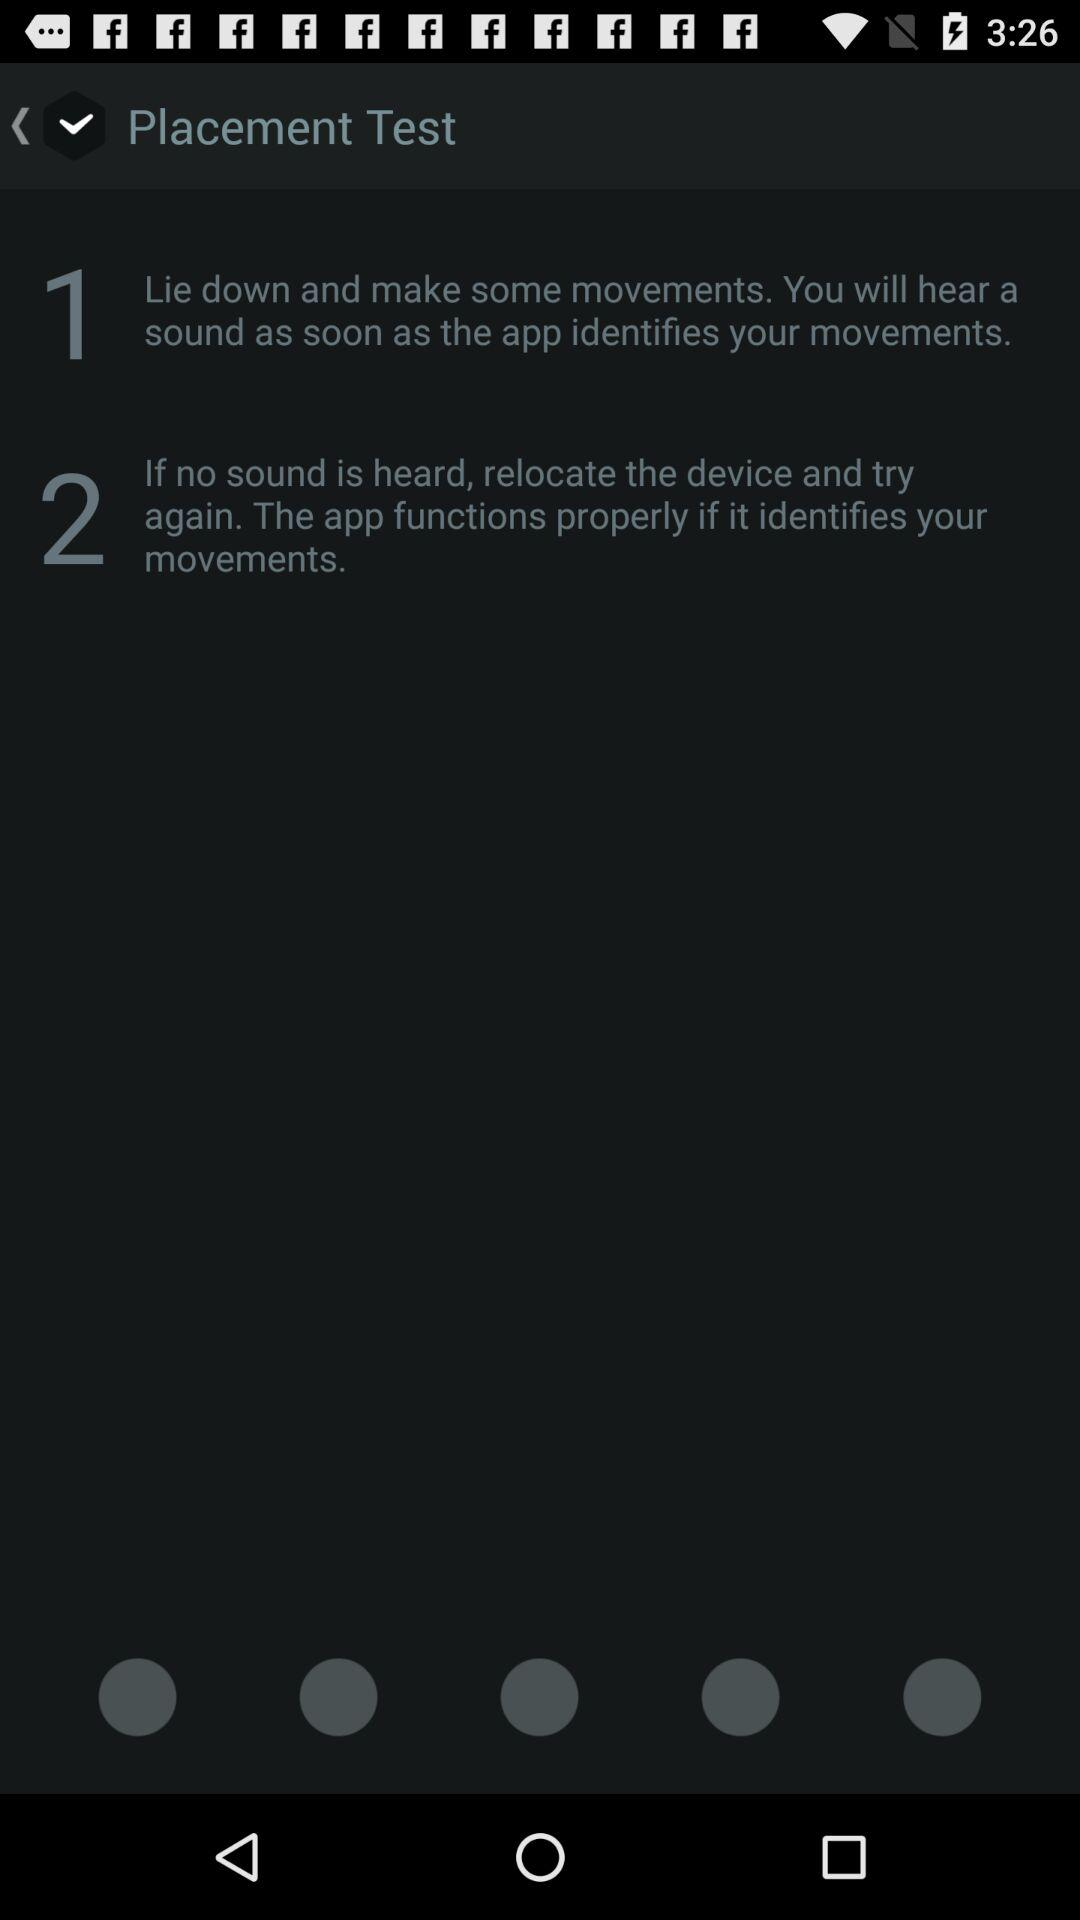What is the duration of the placement test?
When the provided information is insufficient, respond with <no answer>. <no answer> 